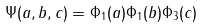<formula> <loc_0><loc_0><loc_500><loc_500>\Psi ( a , b , c ) = \Phi _ { 1 } ( a ) \Phi _ { 1 } ( b ) \Phi _ { 3 } ( c )</formula> 